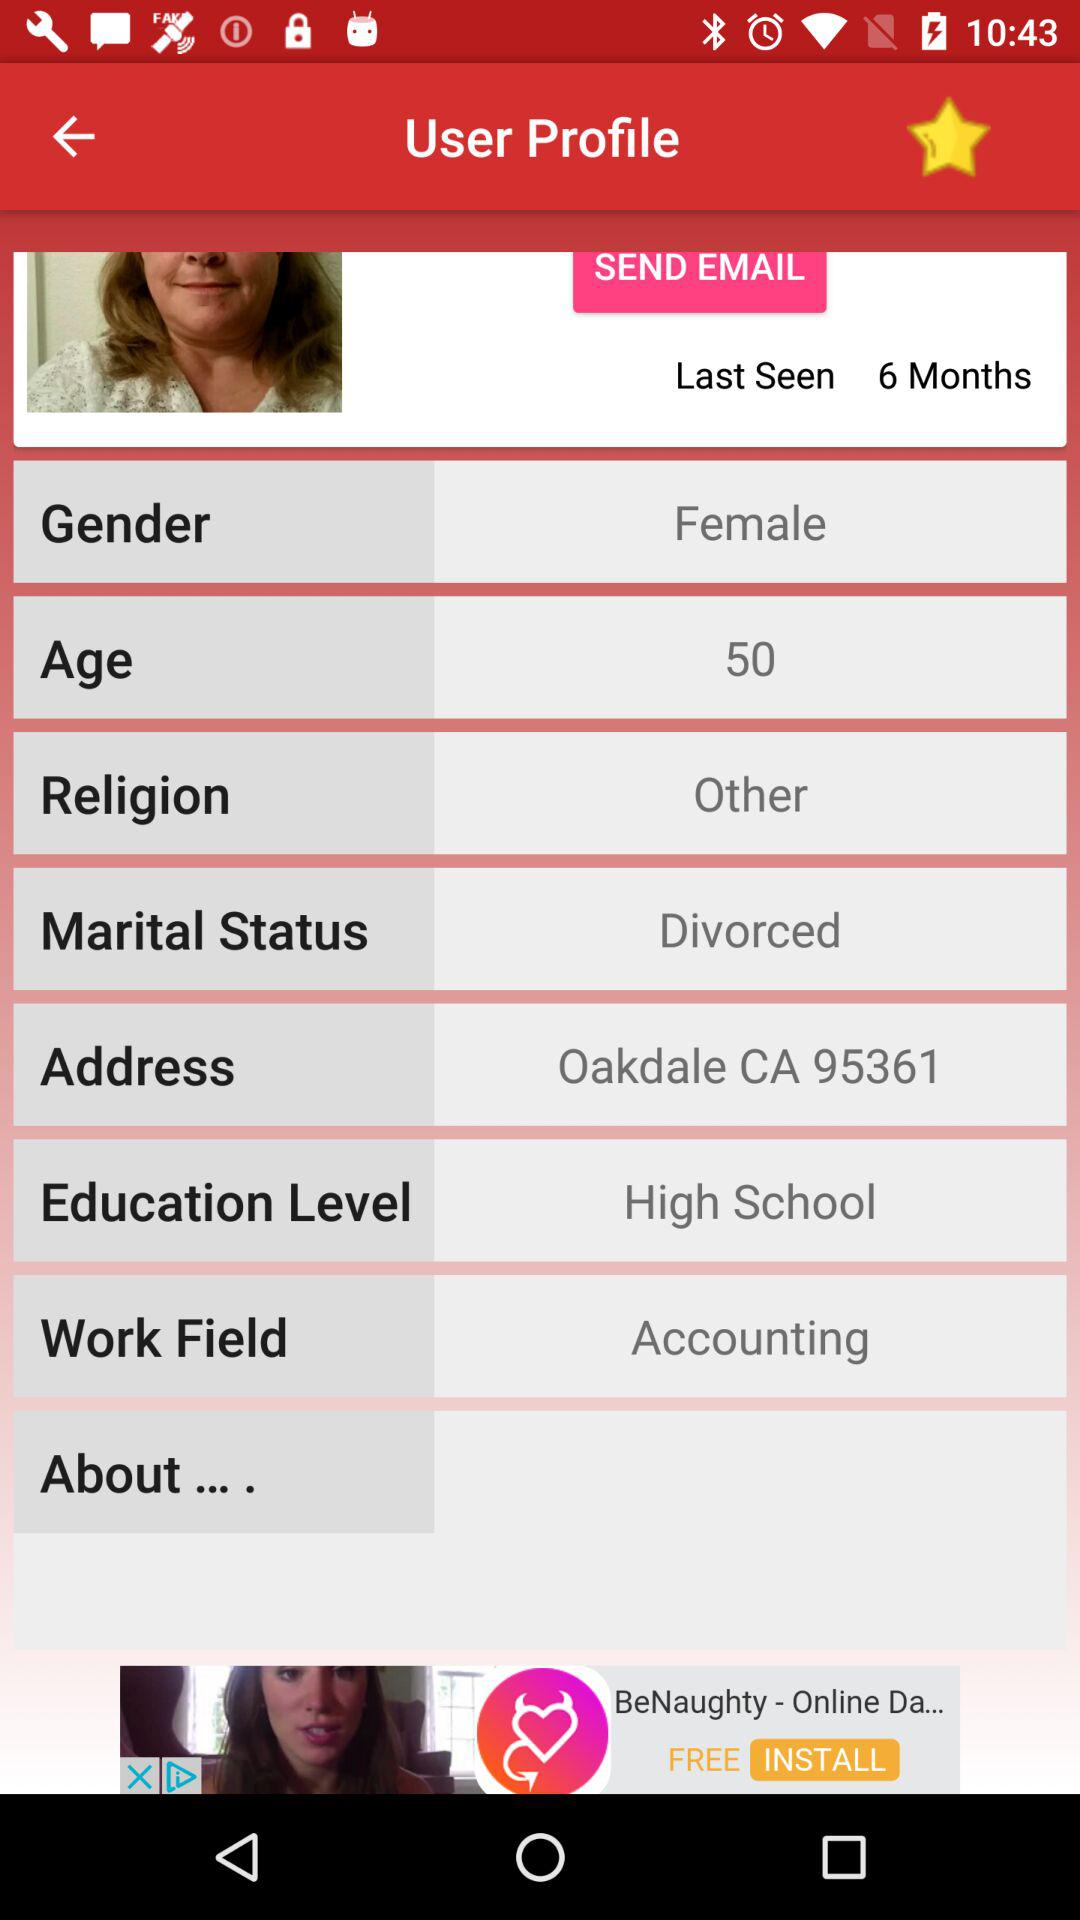What is the username?
When the provided information is insufficient, respond with <no answer>. <no answer> 